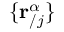<formula> <loc_0><loc_0><loc_500><loc_500>\{ r _ { / j } ^ { \alpha } \}</formula> 